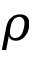<formula> <loc_0><loc_0><loc_500><loc_500>\rho</formula> 